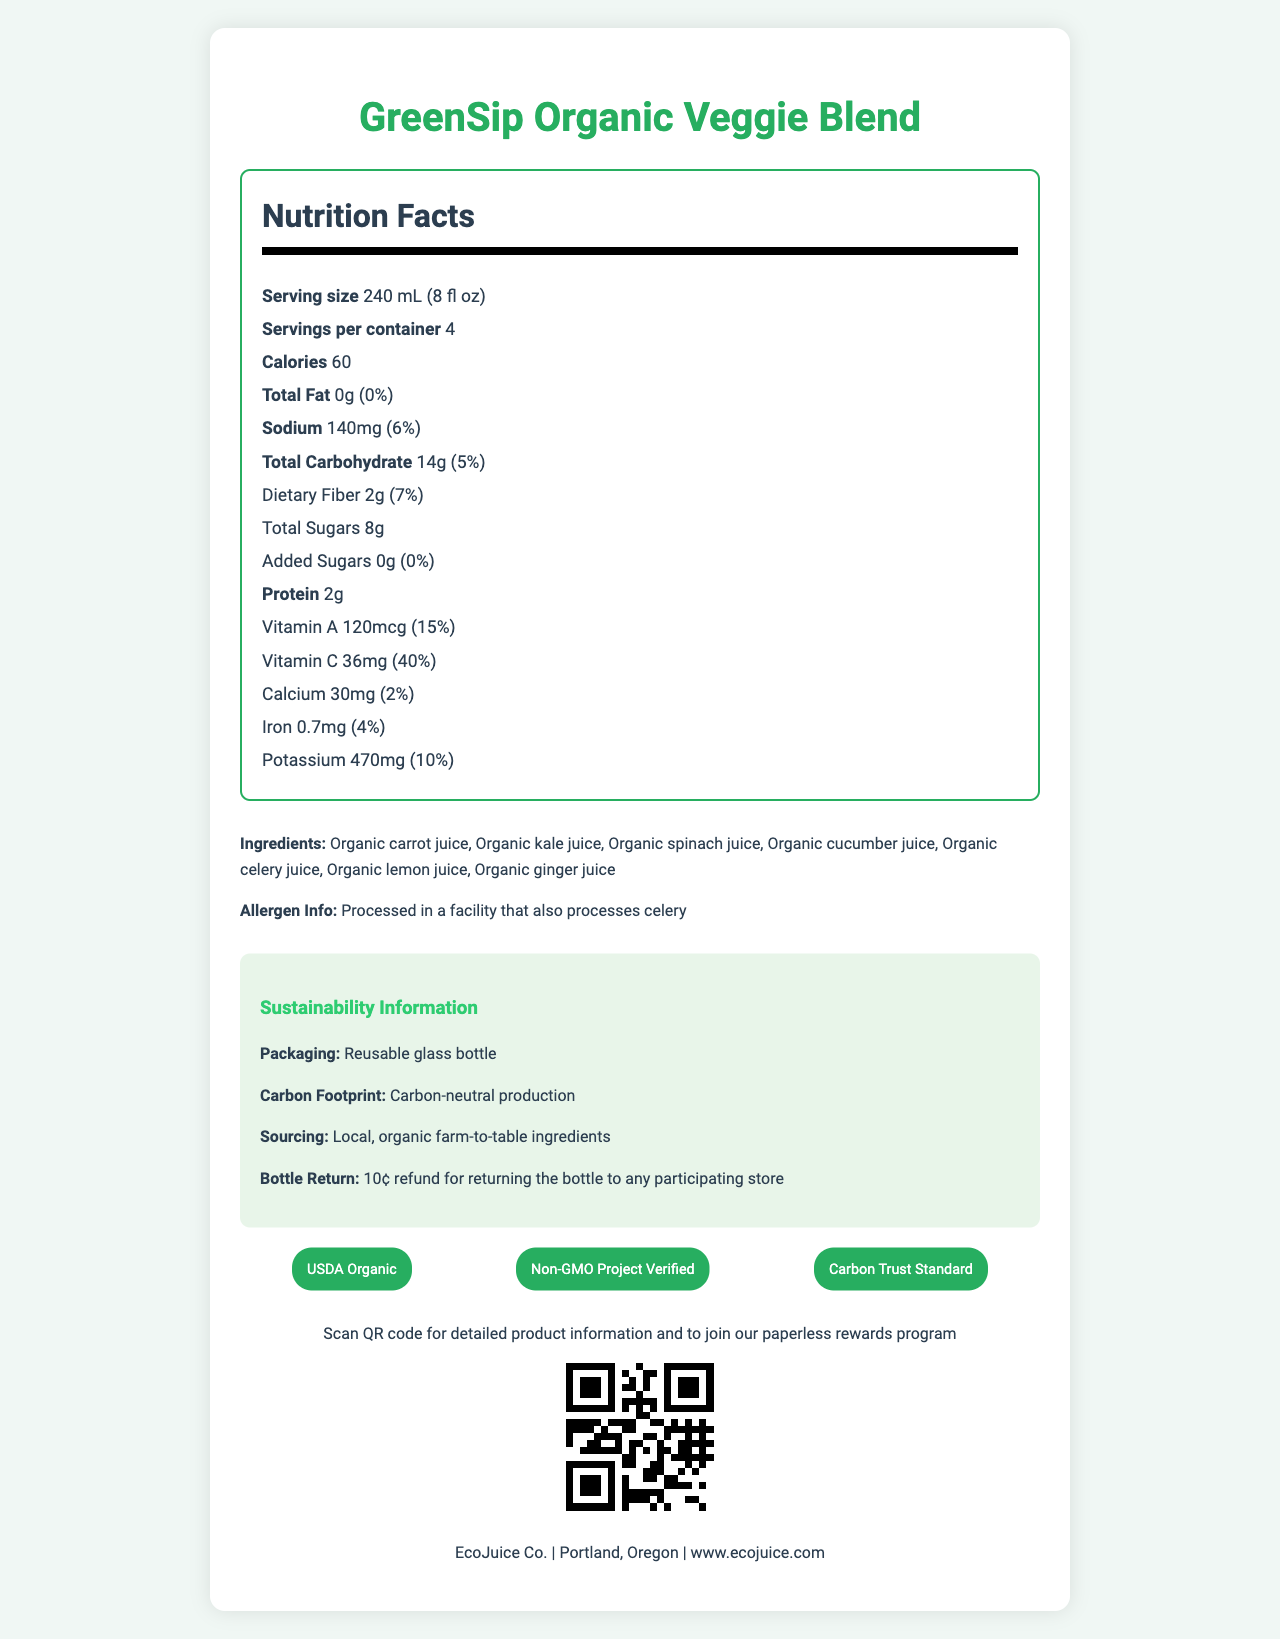what is the serving size of GreenSip Organic Veggie Blend? The serving size is listed as "240 mL (8 fl oz)" on the Nutrition Facts Label under the Nutrition Facts section.
Answer: 240 mL (8 fl oz) how many calories are in one serving? The calories per serving are clearly stated as "60" in the Nutrition Facts section of the document.
Answer: 60 name two vitamins present in GreenSip Organic Veggie Blend Both Vitamin A and Vitamin C are listed in the Nutrition Facts section, with their amounts and daily values.
Answer: Vitamin A, Vitamin C what is the added sugars content in this vegetable juice? The total and added sugars are listed in the Nutrition Facts, showing "Added Sugars 0g".
Answer: 0g how many servings are in one container? The serving information listed shows "Servings per container: 4".
Answer: 4 how much sodium does each serving contain? The sodium content is listed as "140mg" with a daily value of "6%".
Answer: 140mg what certifications does this product have? A. USDA Organic B. Gluten-Free C. Non-GMO Project Verified D. Carbon Trust Standard E. Both A and C F. Both A, C, and D The document states that the product is "USDA Organic," "Non-GMO Project Verified," and "Carbon Trust Standard" certified.
Answer: F. Both A, C, and D which company produces this juice? A. GreenCo B. EcoJuice Co. C. Farm Fresh D. VeggieBlend Inc. The company's name "EcoJuice Co." is mentioned in the company information section at the document's end.
Answer: B. EcoJuice Co. is this product carbon-neutral? The sustainability information section states that the product has "Carbon-neutral production".
Answer: Yes describe the main sustainability initiatives of GreenSip Organic Veggie Blend The sustainability section covers packaging, carbon footprint, sourcing, and bottle return initiatives.
Answer: The product uses a reusable glass bottle, features carbon-neutral production, sources ingredients locally, and offers a 10¢ refund for returning the bottle to participating stores. what is the website to learn more about this product? The company's website "www.ecojuice.com" is listed at the end of the document along with the company information.
Answer: www.ecojuice.com what ingredients make up this juice? The ingredients section lists all these components as part of the juice.
Answer: Organic carrot juice, Organic kale juice, Organic spinach juice, Organic cucumber juice, Organic celery juice, Organic lemon juice, Organic ginger juice how can a customer get more detailed product information? The digital initiative section mentions that scanning the QR code provides detailed product information.
Answer: By scanning the QR code how many grams of dietary fiber are in one serving? The Nutrition Facts section lists "Dietary Fiber 2g" with a daily value of "7%".
Answer: 2g what is the calcium content per serving? The calcium amount per serving is specified as "30mg" with a daily value of "2%".
Answer: 30mg is this product gluten-free? The document does not provide any information regarding whether the product is gluten-free.
Answer: Cannot be determined are there any allergens in GreenSip Organic Veggie Blend? The allergen information section states that the juice is processed in a facility that also processes celery.
Answer: Processed in a facility that also processes celery 